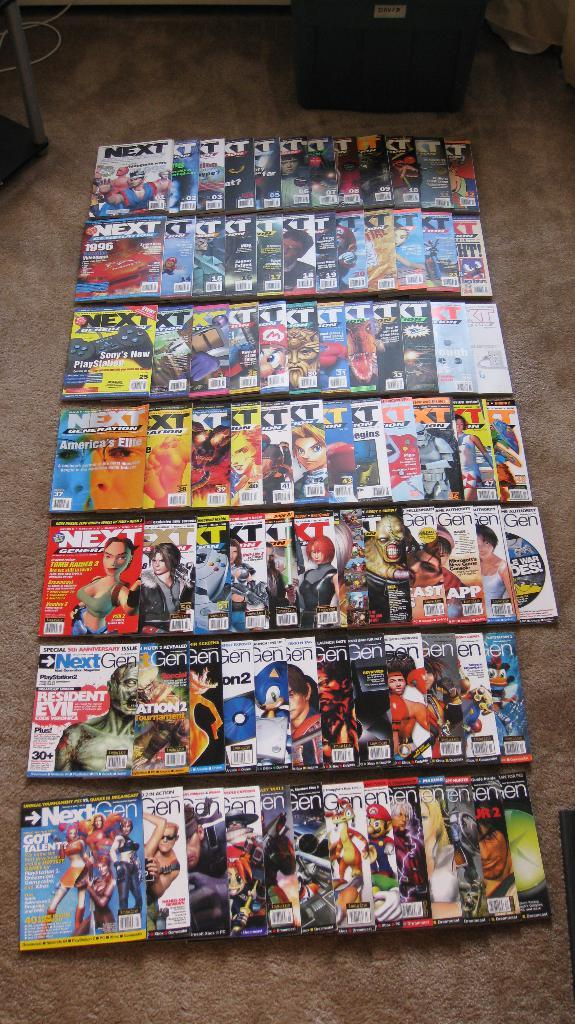What objects are on the ground in the image? There are books on the ground in the image. How many books are visible on the ground? The number of books on the ground cannot be determined from the image alone. What might someone be doing with the books on the ground? It is unclear from the image what someone might be doing with the books, but they could be reading, organizing, or moving them. What type of glue is being used by the father in the image? There is no father or glue present in the image; it only shows books on the ground. 